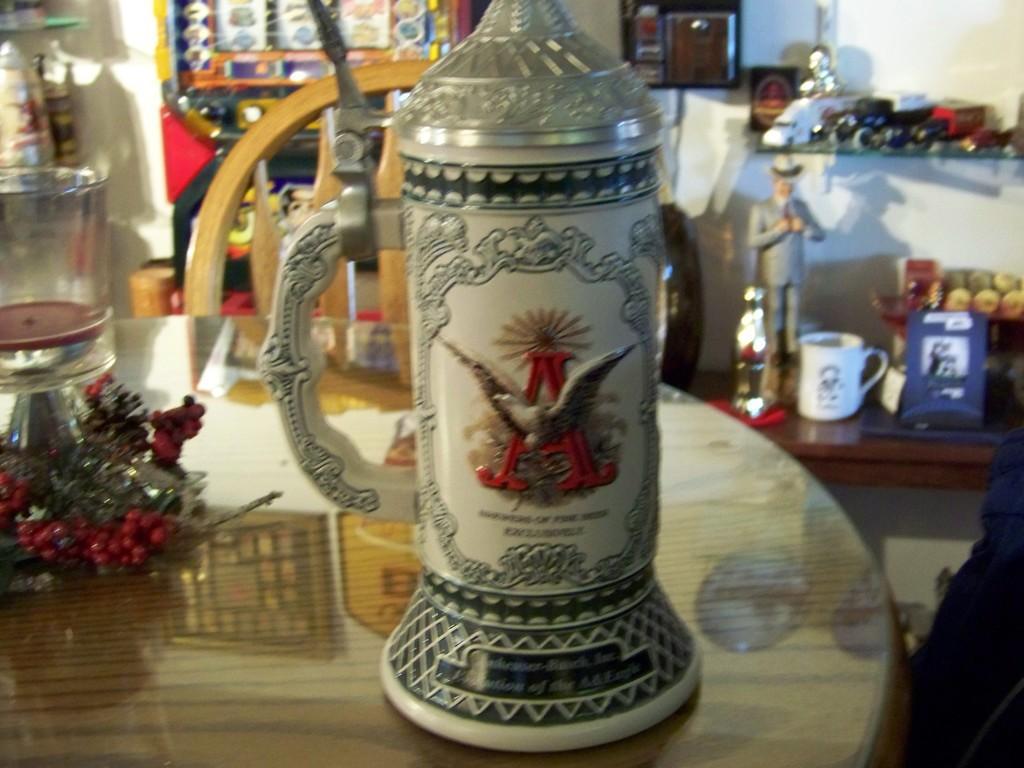Describe this image in one or two sentences. In this image I can see a table in the front and on it I can see a white colour thing, a glass and few other stuffs. In the background I can see number of things on the shelves. I can also see this image is little bit blurry. 